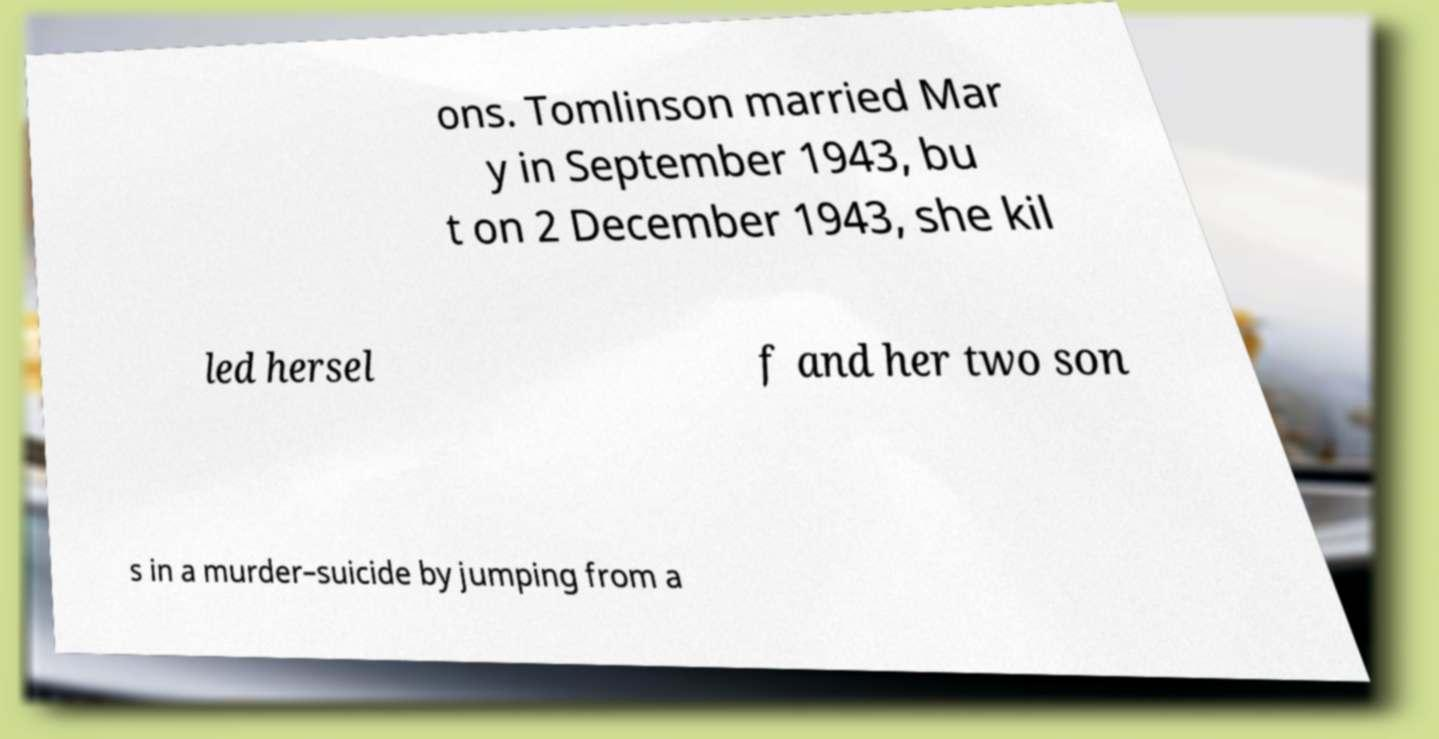For documentation purposes, I need the text within this image transcribed. Could you provide that? ons. Tomlinson married Mar y in September 1943, bu t on 2 December 1943, she kil led hersel f and her two son s in a murder–suicide by jumping from a 